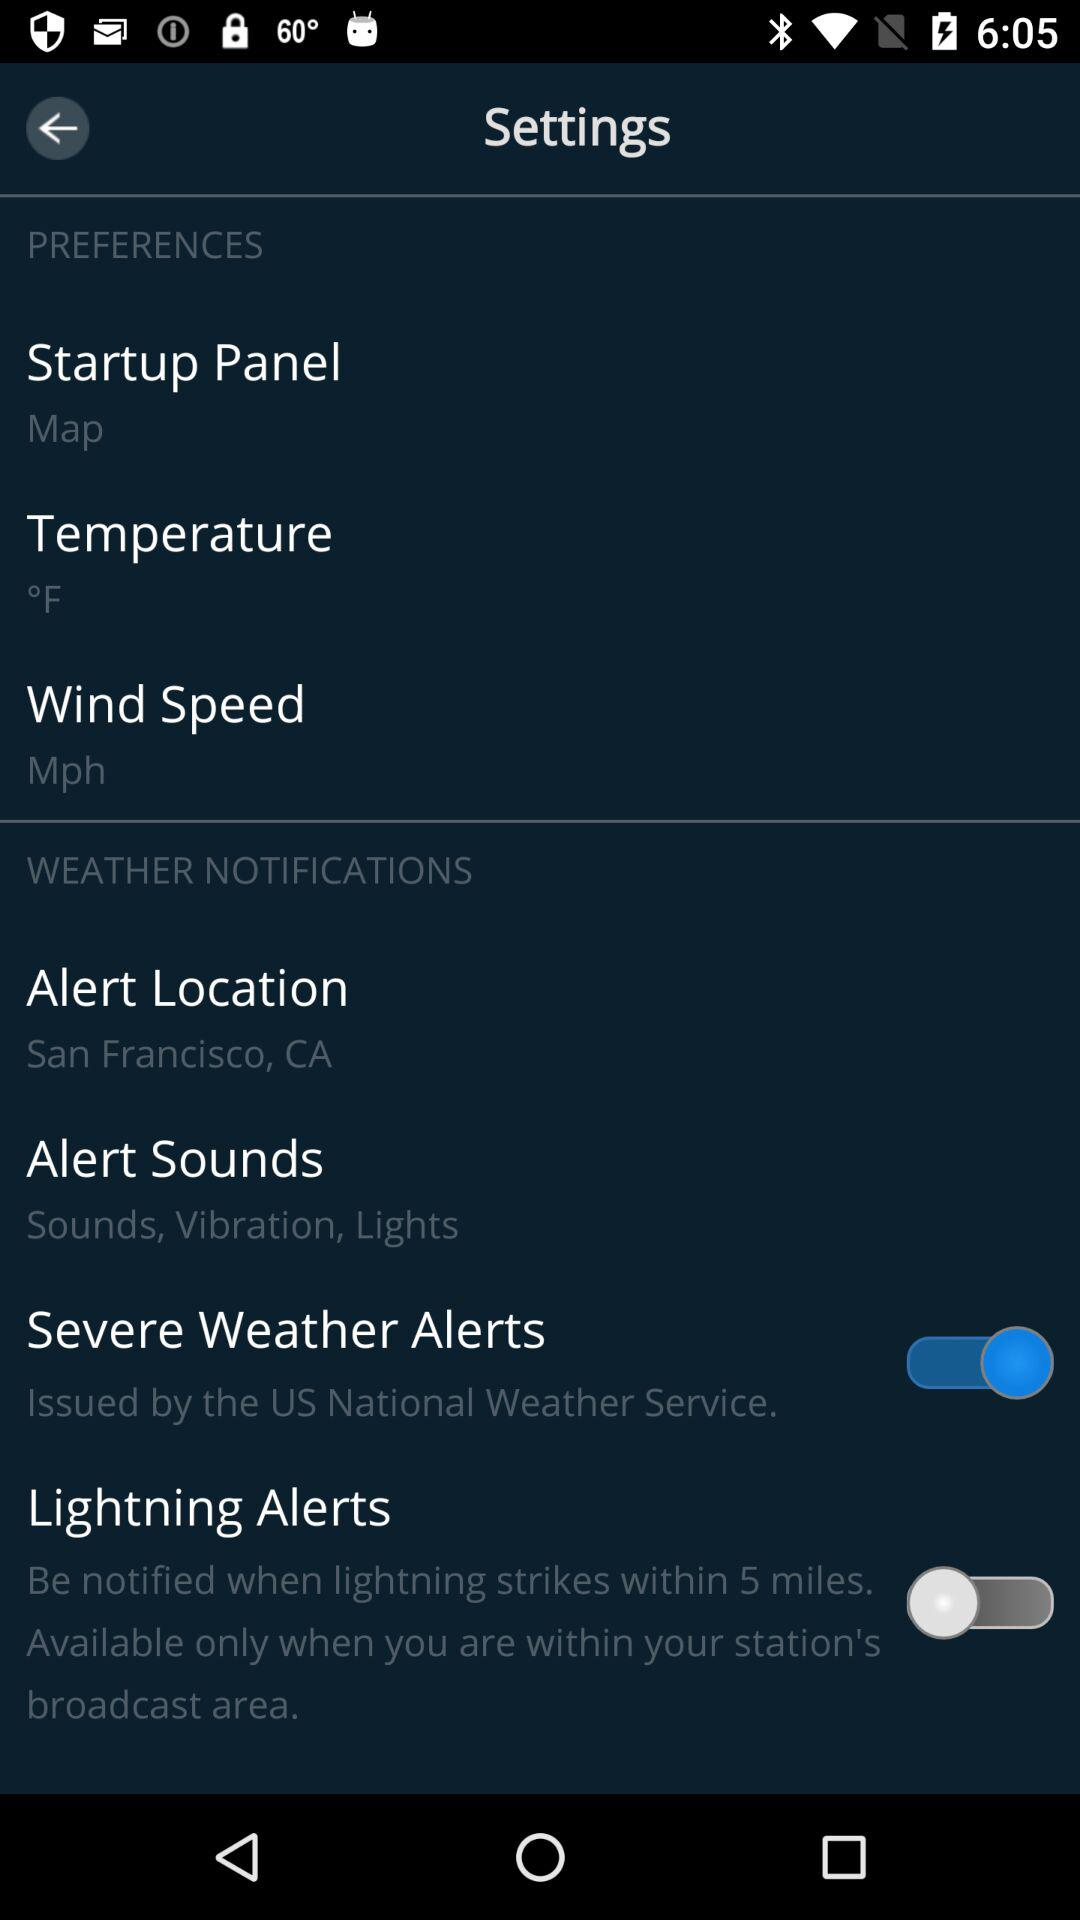What is the unit of wind speed? The unit of wind speed is MPH. 